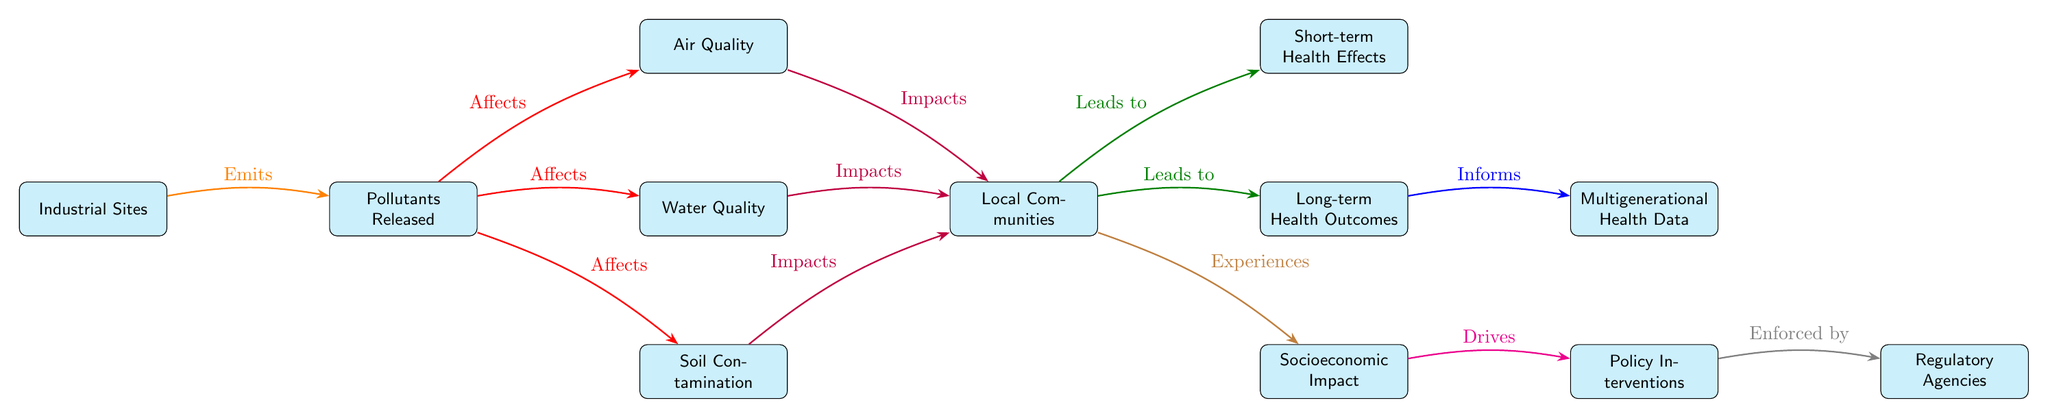What are the main entities represented in the diagram? The entities represented in the diagram include Industrial Sites, Pollutants Released, Air Quality, Water Quality, Soil Contamination, Local Communities, Short-term Health Effects, Long-term Health Outcomes, Multigenerational Health Data, Socioeconomic Impact, Policy Interventions, and Regulatory Agencies.
Answer: Industrial Sites, Pollutants Released, Air Quality, Water Quality, Soil Contamination, Local Communities, Short-term Health Effects, Long-term Health Outcomes, Multigenerational Health Data, Socioeconomic Impact, Policy Interventions, Regulatory Agencies How many edges are present in the diagram? By counting the arrows connecting the nodes, there are a total of 10 edges in the diagram.
Answer: 10 What does 'Industrials Sites' emit? According to the diagram, Industrial Sites emit Pollutants Released.
Answer: Pollutants Released Which factors impact Local Communities? The diagram shows that Air Quality, Water Quality, and Soil Contamination all impact Local Communities.
Answer: Air Quality, Water Quality, Soil Contamination How do Local Communities experience negative effects? Local Communities experience Short-term Health Effects and Long-term Health Outcomes due to pollutants affecting air, water, and soil quality.
Answer: Short-term Health Effects, Long-term Health Outcomes Which entity informs Multigenerational Health Data? The Long-term Health Outcomes entity informs Multigenerational Health Data according to the relationship indicated in the diagram.
Answer: Long-term Health Outcomes How does Socioeconomic Impact relate to Policy Interventions? Socioeconomic Impact drives Policy Interventions, showing a causal connection based on the diagram's arrows.
Answer: Drives What is the flow from 'Regulatory Agencies' in the diagram? Regulatory Agencies are enforced by Policy Interventions, indicating that these interventions require enforcement by authorities.
Answer: Enforced by What is the impact of pollutants on air quality? Pollutants released have a direct negative effect on air quality, as depicted by an arrow originating from 'Pollutants Released' to 'Air Quality'.
Answer: Affects What are the indirect impacts of Local Communities? Local Communities comprise Short-term Health Effects, Long-term Health Outcomes, and Socioeconomic Impact, indicating indirect hazards stemming from health-related outcomes.
Answer: Short-term Health Effects, Long-term Health Outcomes, Socioeconomic Impact 